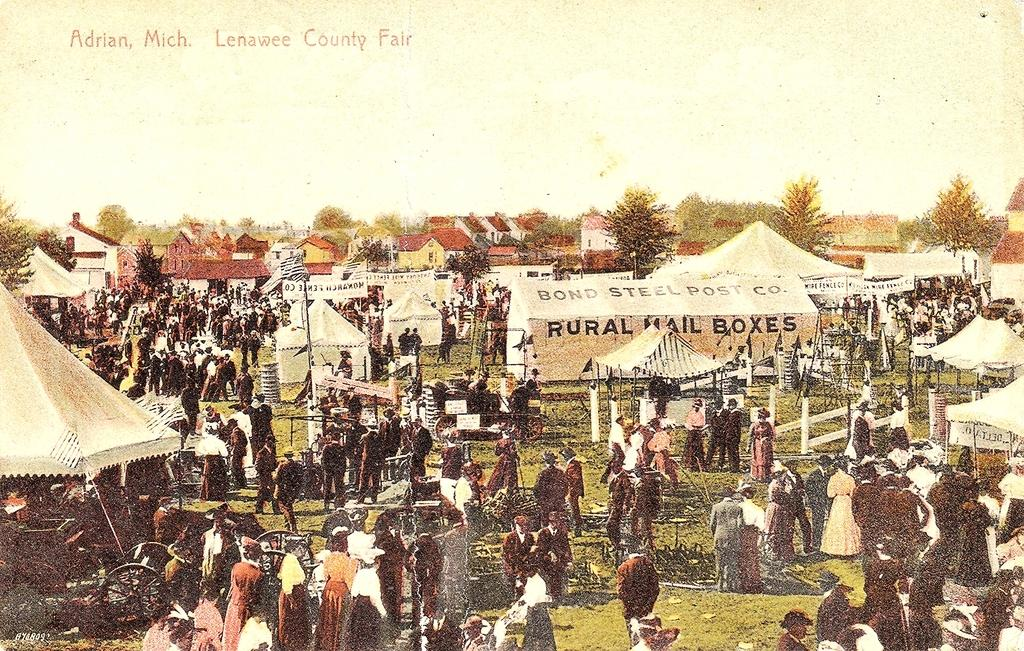<image>
Create a compact narrative representing the image presented. The old postcard from the Lenawee County Fair shows a tent devoted to rural mailboxes. 